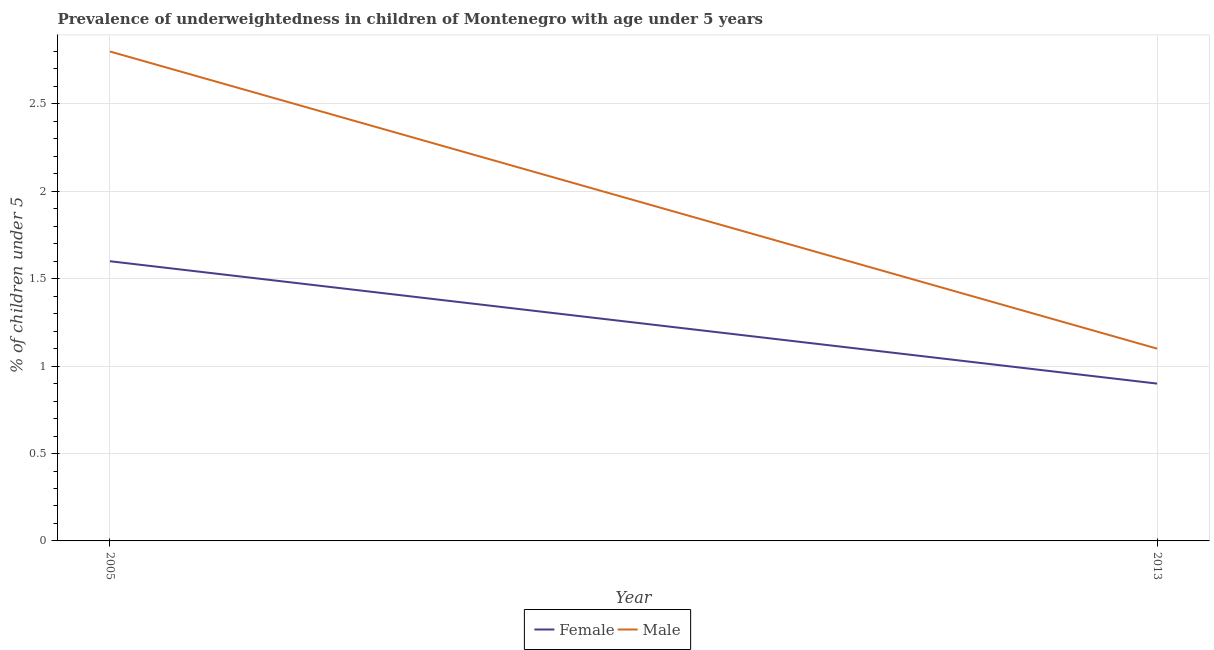How many different coloured lines are there?
Your response must be concise. 2. Does the line corresponding to percentage of underweighted female children intersect with the line corresponding to percentage of underweighted male children?
Ensure brevity in your answer.  No. Is the number of lines equal to the number of legend labels?
Give a very brief answer. Yes. What is the percentage of underweighted male children in 2013?
Provide a succinct answer. 1.1. Across all years, what is the maximum percentage of underweighted female children?
Make the answer very short. 1.6. Across all years, what is the minimum percentage of underweighted male children?
Provide a short and direct response. 1.1. In which year was the percentage of underweighted female children maximum?
Ensure brevity in your answer.  2005. In which year was the percentage of underweighted female children minimum?
Keep it short and to the point. 2013. What is the total percentage of underweighted female children in the graph?
Your answer should be very brief. 2.5. What is the difference between the percentage of underweighted female children in 2005 and that in 2013?
Offer a terse response. 0.7. What is the average percentage of underweighted female children per year?
Make the answer very short. 1.25. In the year 2005, what is the difference between the percentage of underweighted female children and percentage of underweighted male children?
Your answer should be very brief. -1.2. In how many years, is the percentage of underweighted male children greater than 2.5 %?
Keep it short and to the point. 1. What is the ratio of the percentage of underweighted male children in 2005 to that in 2013?
Offer a terse response. 2.55. Is the percentage of underweighted male children in 2005 less than that in 2013?
Your answer should be compact. No. Does the percentage of underweighted male children monotonically increase over the years?
Offer a very short reply. No. Is the percentage of underweighted male children strictly greater than the percentage of underweighted female children over the years?
Give a very brief answer. Yes. Is the percentage of underweighted female children strictly less than the percentage of underweighted male children over the years?
Provide a succinct answer. Yes. How many lines are there?
Ensure brevity in your answer.  2. How many years are there in the graph?
Your response must be concise. 2. Does the graph contain any zero values?
Give a very brief answer. No. Where does the legend appear in the graph?
Your answer should be very brief. Bottom center. What is the title of the graph?
Your answer should be very brief. Prevalence of underweightedness in children of Montenegro with age under 5 years. What is the label or title of the Y-axis?
Offer a terse response.  % of children under 5. What is the  % of children under 5 in Female in 2005?
Your answer should be very brief. 1.6. What is the  % of children under 5 of Male in 2005?
Offer a terse response. 2.8. What is the  % of children under 5 in Female in 2013?
Provide a succinct answer. 0.9. What is the  % of children under 5 in Male in 2013?
Give a very brief answer. 1.1. Across all years, what is the maximum  % of children under 5 of Female?
Offer a very short reply. 1.6. Across all years, what is the maximum  % of children under 5 of Male?
Ensure brevity in your answer.  2.8. Across all years, what is the minimum  % of children under 5 of Female?
Keep it short and to the point. 0.9. Across all years, what is the minimum  % of children under 5 of Male?
Make the answer very short. 1.1. What is the total  % of children under 5 of Male in the graph?
Give a very brief answer. 3.9. What is the difference between the  % of children under 5 in Female in 2005 and the  % of children under 5 in Male in 2013?
Provide a short and direct response. 0.5. What is the average  % of children under 5 of Female per year?
Offer a very short reply. 1.25. What is the average  % of children under 5 of Male per year?
Offer a terse response. 1.95. In the year 2005, what is the difference between the  % of children under 5 of Female and  % of children under 5 of Male?
Your answer should be very brief. -1.2. What is the ratio of the  % of children under 5 in Female in 2005 to that in 2013?
Provide a succinct answer. 1.78. What is the ratio of the  % of children under 5 of Male in 2005 to that in 2013?
Provide a short and direct response. 2.55. What is the difference between the highest and the second highest  % of children under 5 in Female?
Ensure brevity in your answer.  0.7. 